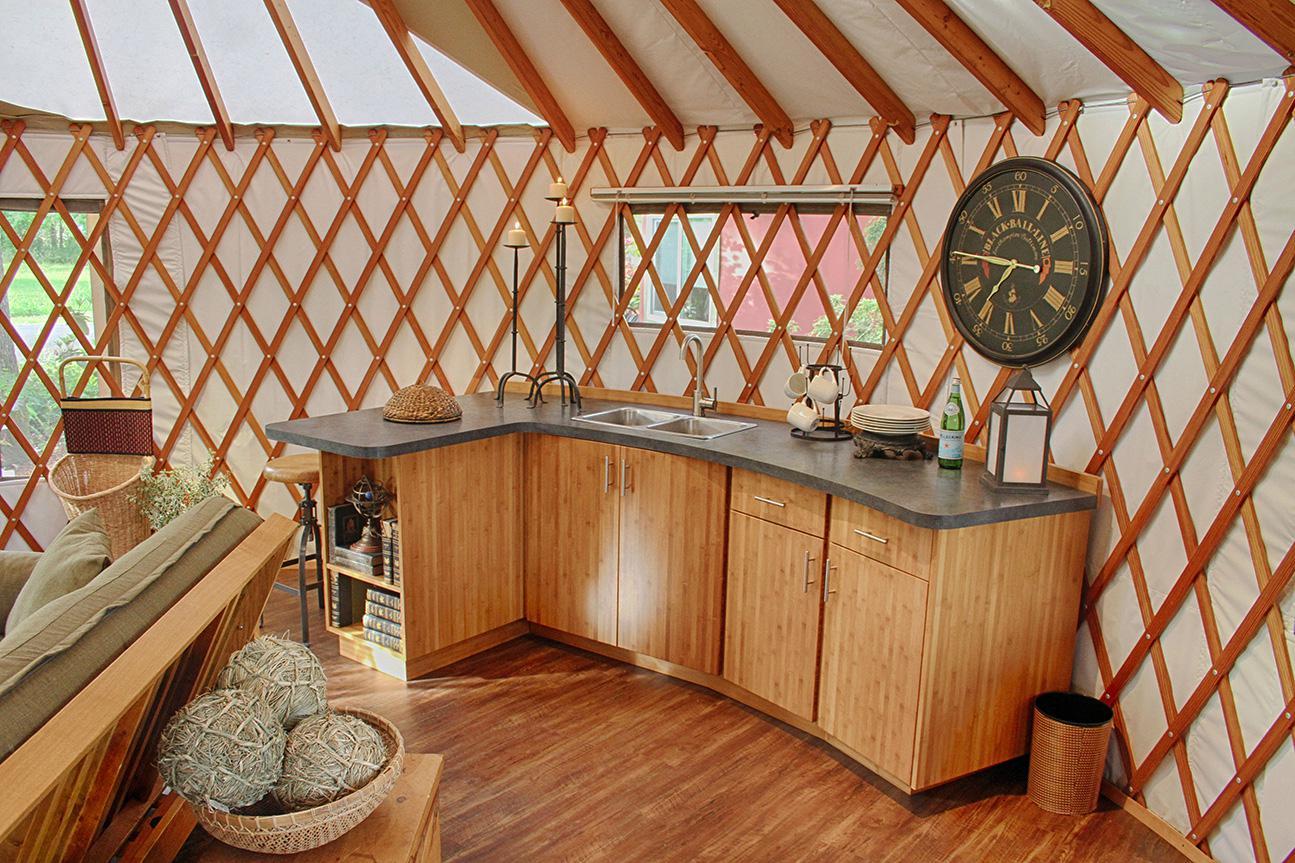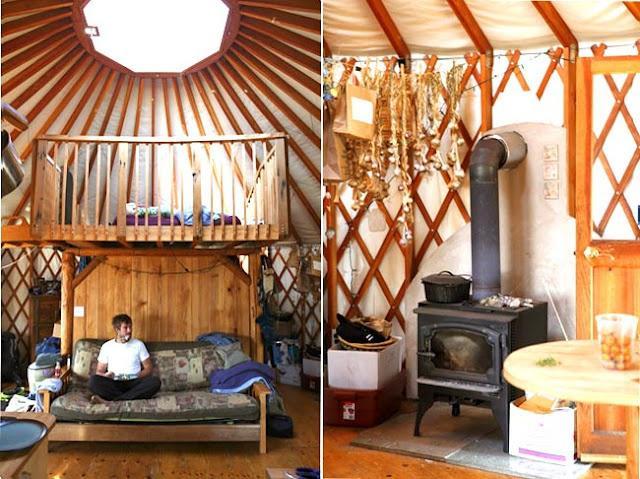The first image is the image on the left, the second image is the image on the right. Assess this claim about the two images: "One of the images shows a second floor balcony area with a wooden railing.". Correct or not? Answer yes or no. Yes. 